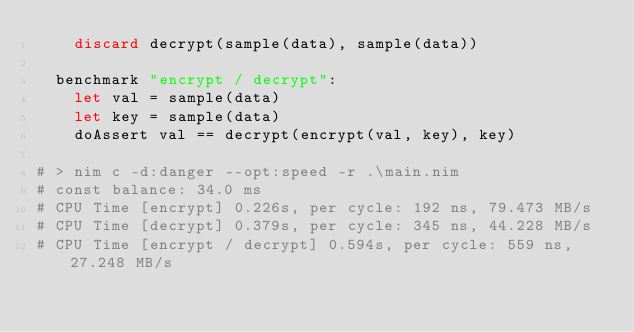Convert code to text. <code><loc_0><loc_0><loc_500><loc_500><_Nim_>    discard decrypt(sample(data), sample(data))

  benchmark "encrypt / decrypt":
    let val = sample(data)
    let key = sample(data)
    doAssert val == decrypt(encrypt(val, key), key)

# > nim c -d:danger --opt:speed -r .\main.nim
# const balance: 34.0 ms
# CPU Time [encrypt] 0.226s, per cycle: 192 ns, 79.473 MB/s
# CPU Time [decrypt] 0.379s, per cycle: 345 ns, 44.228 MB/s
# CPU Time [encrypt / decrypt] 0.594s, per cycle: 559 ns, 27.248 MB/s</code> 